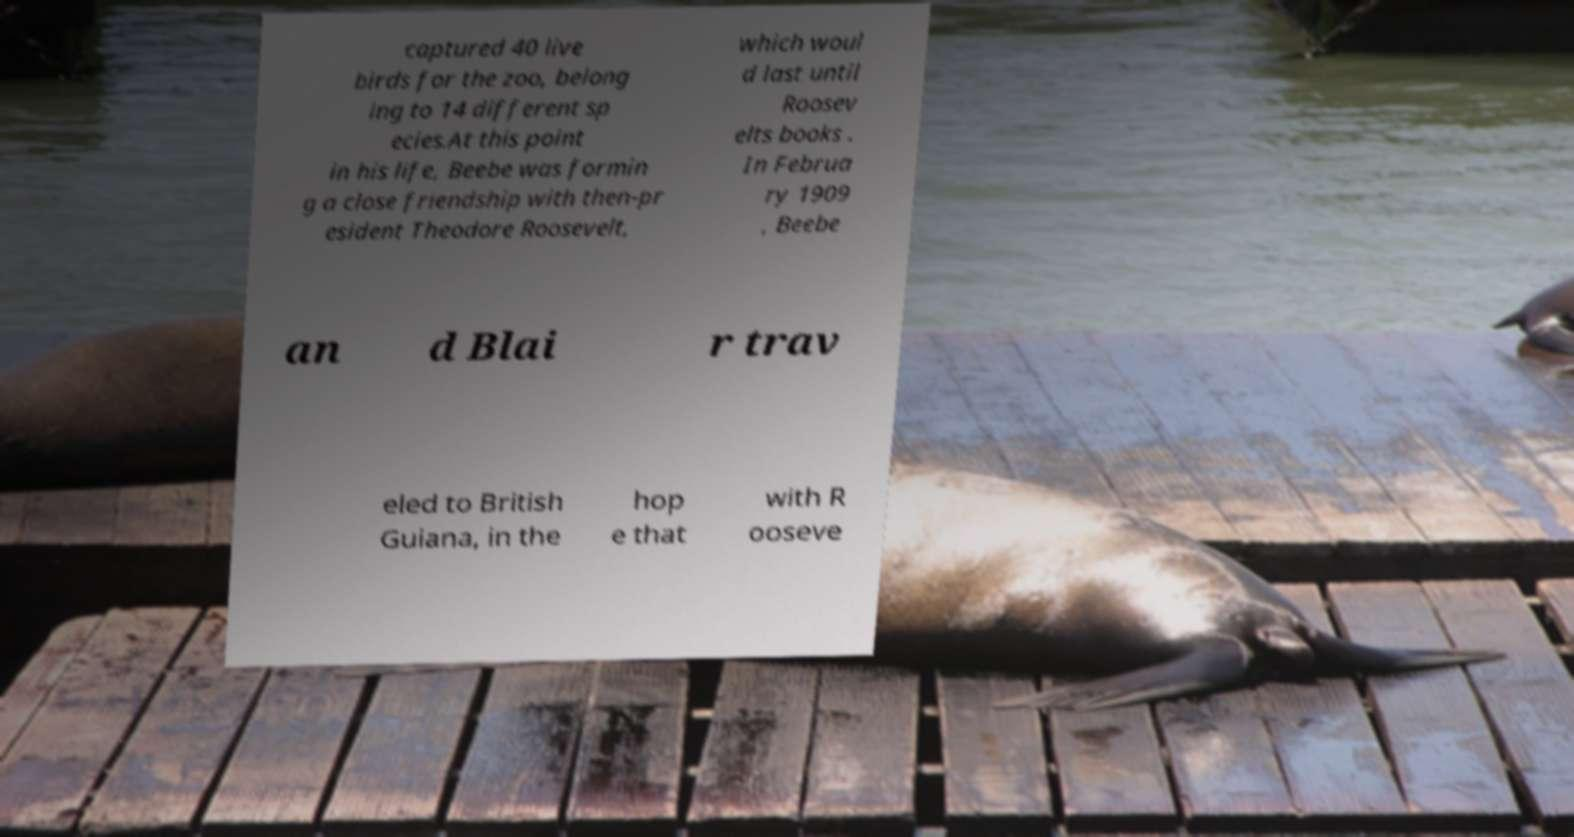Can you accurately transcribe the text from the provided image for me? captured 40 live birds for the zoo, belong ing to 14 different sp ecies.At this point in his life, Beebe was formin g a close friendship with then-pr esident Theodore Roosevelt, which woul d last until Roosev elts books . In Februa ry 1909 , Beebe an d Blai r trav eled to British Guiana, in the hop e that with R ooseve 